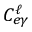<formula> <loc_0><loc_0><loc_500><loc_500>C _ { e \gamma } ^ { \ell }</formula> 